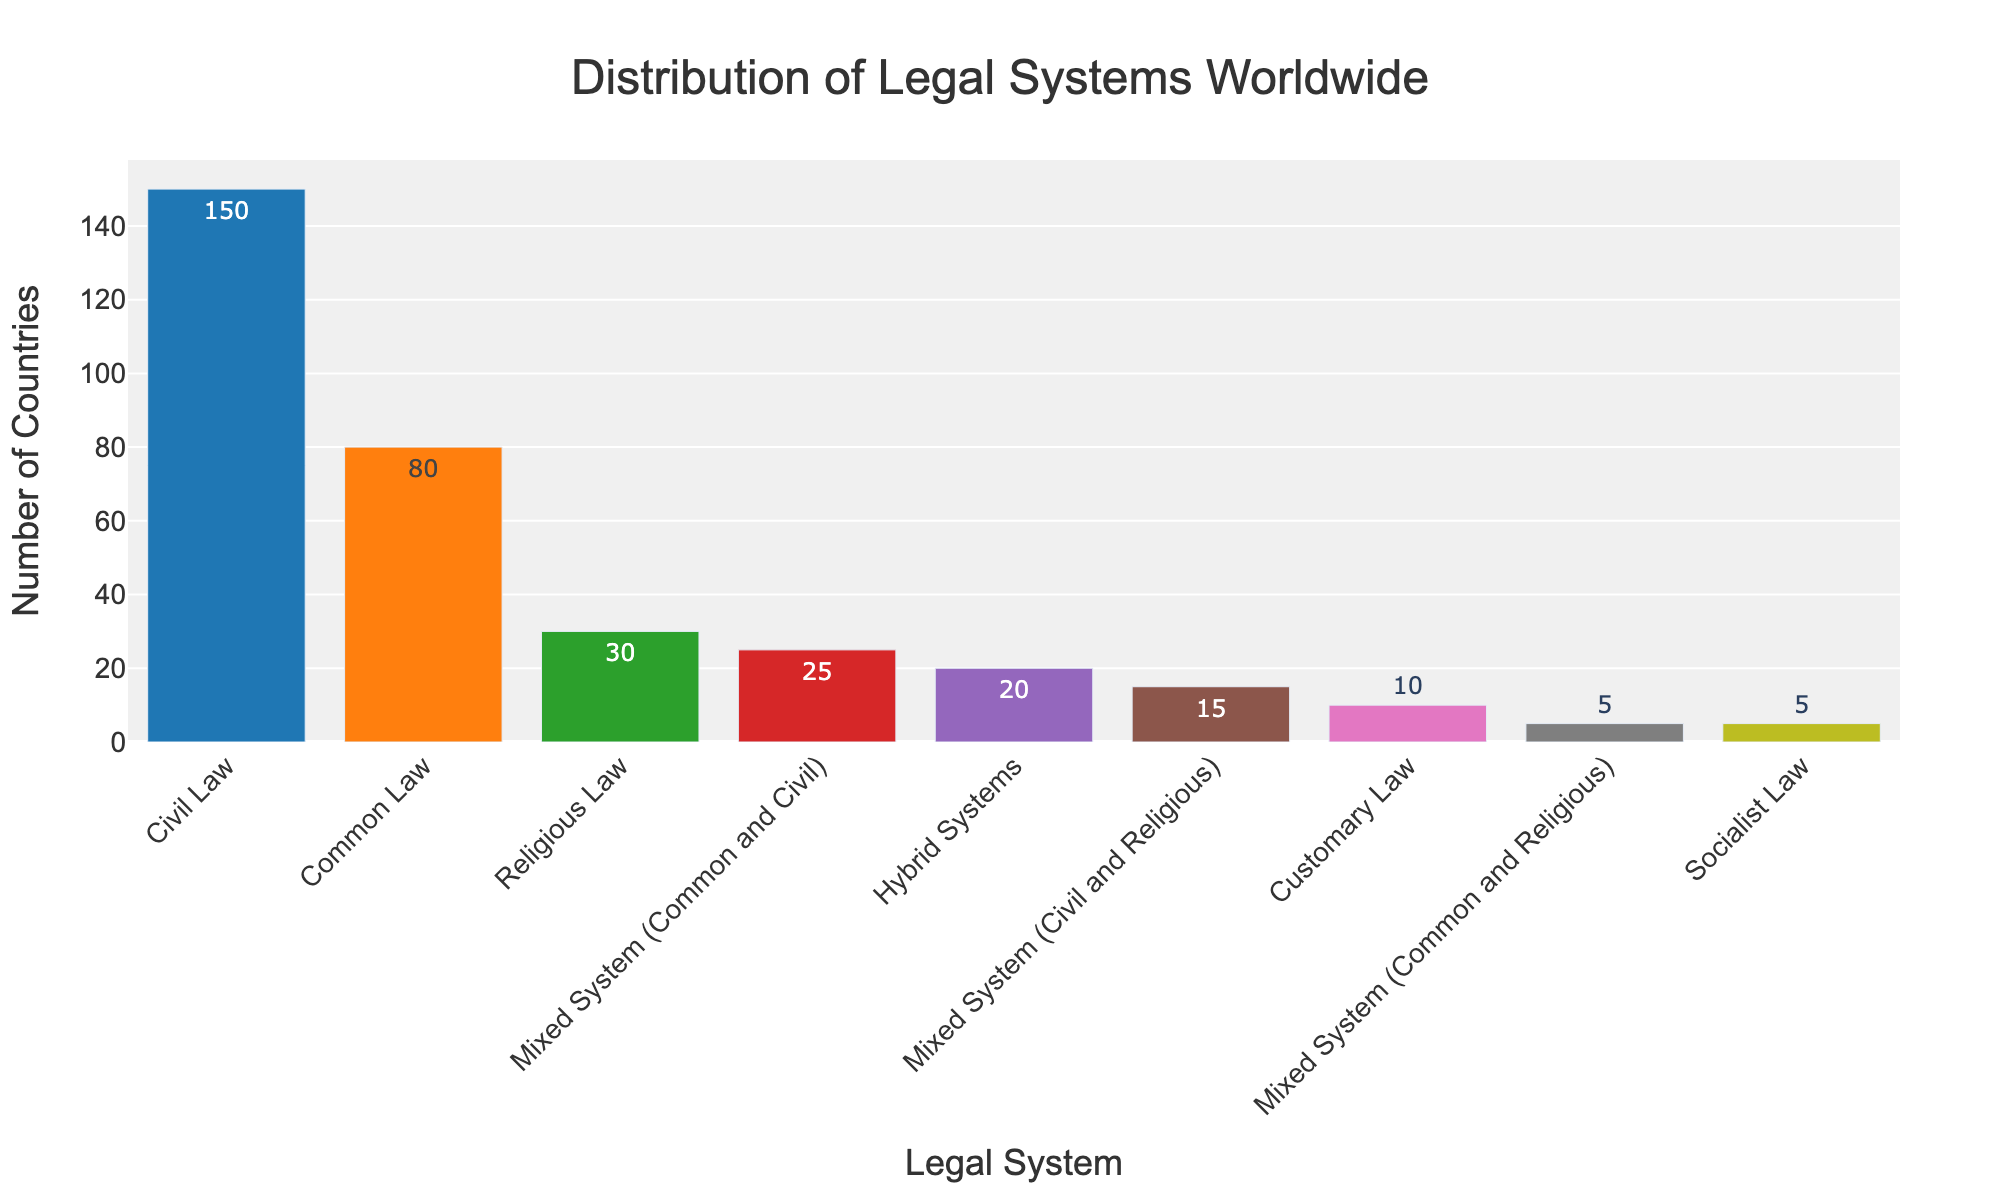What type of legal system is represented by the tallest bar in the chart? The tallest bar in the chart represents the legal system with the highest number of countries. By looking at the height and labels, we can identify it as "Civil Law."
Answer: Civil Law How many countries use mixed legal systems that involve both common and civil law? To determine this, look for the bar labeled "Mixed System (Common and Civil)" and check its height or label, which represents the number of countries. The label reads 25.
Answer: 25 What is the total number of countries that use either customary law or socialist law? Sum the values for "Customary Law" and "Socialist Law." Customary Law has 10 countries, and Socialist Law has 5 countries. The total is 10 + 5 = 15.
Answer: 15 Which legal system is used by fewer countries: religious law or hybrid systems? Compare the heights or labels of the bars for "Religious Law" and "Hybrid Systems." Religious Law is used by 30 countries, and Hybrid Systems are used by 20 countries, so Hybrid Systems are used by fewer countries.
Answer: Hybrid Systems What is the difference in the number of countries using civil law and common law systems? Check the values for both "Civil Law" and "Common Law." Civil Law has 150 countries, and Common Law has 80 countries. The difference is 150 - 80 = 70.
Answer: 70 How many countries in total adopt some form of mixed legal system according to the chart? Sum the number of countries for all mixed systems: "Mixed System (Common and Civil)" has 25, "Mixed System (Civil and Religious)" has 15, and "Mixed System (Common and Religious)" has 5. The total is 25 + 15 + 5 = 45.
Answer: 45 Which legal system is depicted with the least number of countries? Identify the bar with the shortest height. The label shows it as "Socialist Law," which has 5 countries.
Answer: Socialist Law Do more countries use civil law systems or a combination of customary, socialist, and hybrid systems? Sum the number of countries for Customary Law (10), Socialist Law (5), and Hybrid Systems (20), which is 10 + 5 + 20 = 35. Compare this to Civil Law, which has 150. So, more countries use Civil Law.
Answer: Civil Law 